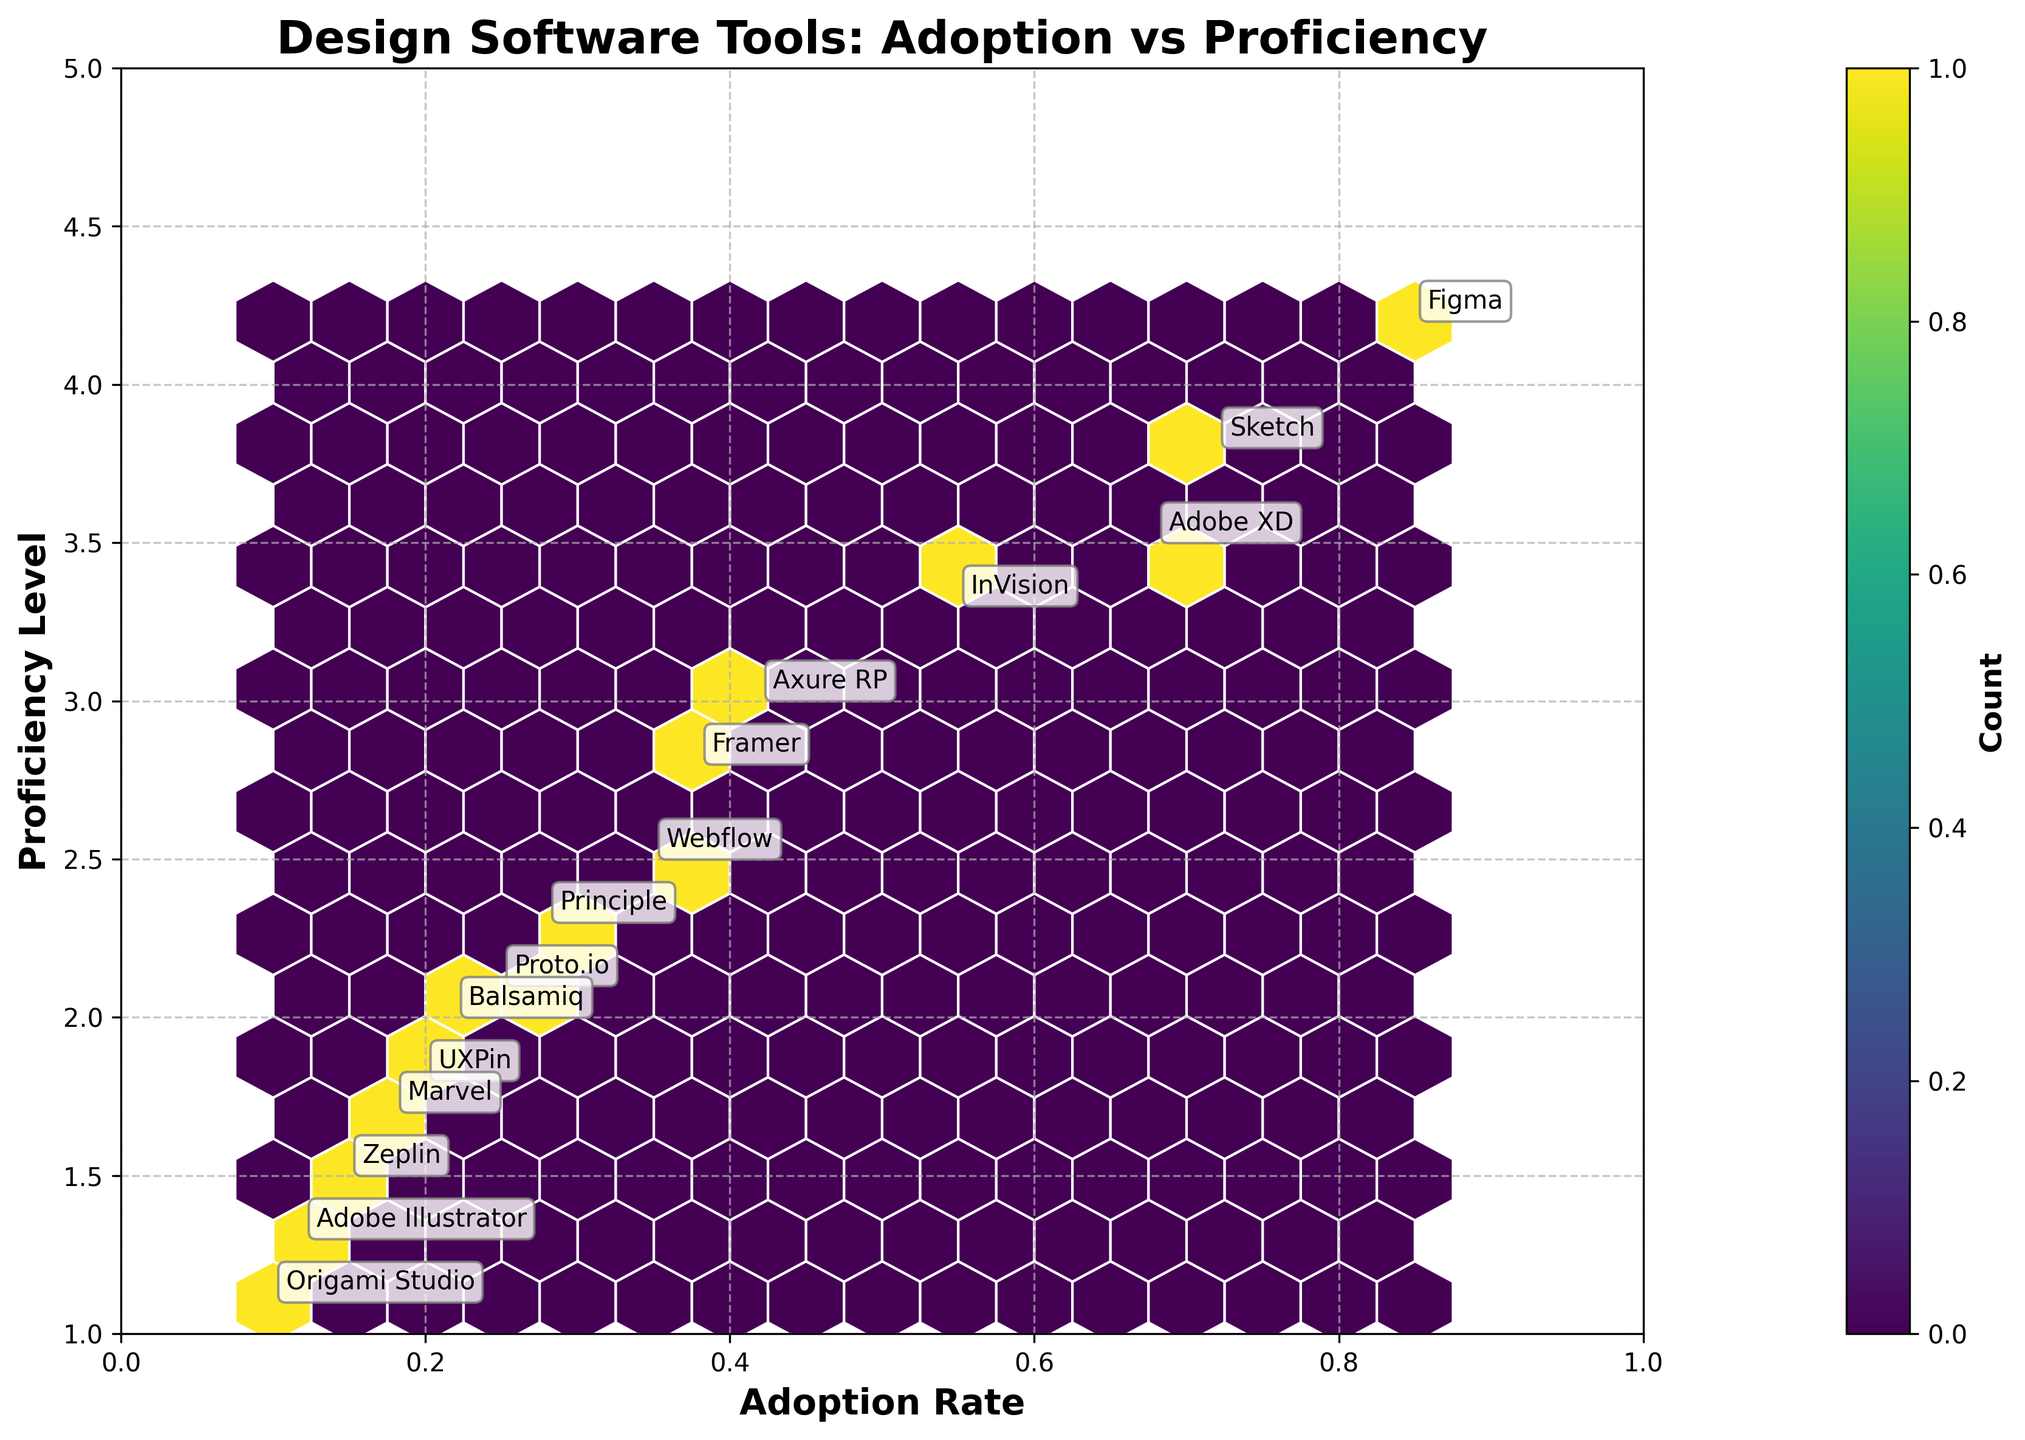What is the title of the hexbin plot? The title of a plot is usually displayed at the top, it helps in quickly understanding what the visualizations represent. In this case, the title is 'Design Software Tools: Adoption vs Proficiency'.
Answer: Design Software Tools: Adoption vs Proficiency What is the range of the Adoption Rate axis? The range of an axis can be determined by identifying its minimum and maximum values shown along the axis. Here, the Adoption Rate axis has a range from 0 to 1.
Answer: 0 to 1 How many tools have an adoption rate above 0.5? To find the number of tools with an adoption rate above 0.5, count the points positioned to the right of the 0.5 mark on the Adoption Rate axis. There are 4 such tools.
Answer: 4 Which tool has the highest proficiency level? The tool with the highest proficiency level can be identified by locating the point that is furthest up on the Proficiency Level axis. Here, the tool is Figma, with a proficiency level of 4.2.
Answer: Figma What is the tool with the lowest proficiency level? Look for the point that is lowest on the Proficiency Level axis, which signifies the lowest proficiency level. The tool with the lowest proficiency level is Origami Studio at 1.1.
Answer: Origami Studio What is the range of the Proficiency Level axis? Identify the minimum and maximum values indicated on the Proficiency Level axis to find the range. The Proficiency Level axis ranges from 1 to 5.
Answer: 1 to 5 How does Sketch compare to Adobe XD in terms of adoption rate and proficiency level? Compare the positions of Sketch and Adobe XD on both the Adoption Rate and Proficiency Level axes. Sketch has a higher adoption rate (0.72 vs 0.68) and a higher proficiency level (3.8 vs 3.5) than Adobe XD.
Answer: Sketch has higher rates in both categories Which tool has a similar adoption rate to Axure RP but a higher proficiency level? Locate Axure RP on the plot and look for another point with a similar adoption rate but positioned higher on the Proficiency Level axis. Adobe XD has a similar adoption rate (0.68) but a higher proficiency level (3.5 compared to 3.0).
Answer: Adobe XD What is the average proficiency level of tools with an adoption rate below 0.3? Identify the tools with an adoption rate below 0.3 by looking at points to the left of the 0.3 mark. Compute the average proficiency level of Principle (2.3), Proto.io (2.1), Balsamiq (2.0), UXPin (1.8), Marvel (1.7), Zeplin (1.5), Adobe Illustrator (1.3), and Origami Studio (1.1). The calculation is (2.3 + 2.1 + 2.0 + 1.8 + 1.7 + 1.5 + 1.3 + 1.1) / 8 = 1.725.
Answer: 1.725 How does the number of tools in the central region compare to those in the upper left? To answer this, observe the density of points shown by the hexbin colors in each area. The central region (Adoption Rate ~0.5, Proficiency Level ~3) shows a higher concentration of points (darker colors) compared to the upper left corner (low Adoption Rate and high Proficiency Level), which has fewer or no points.
Answer: The central region has more tools 